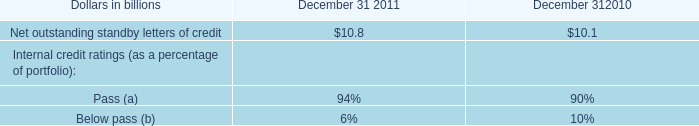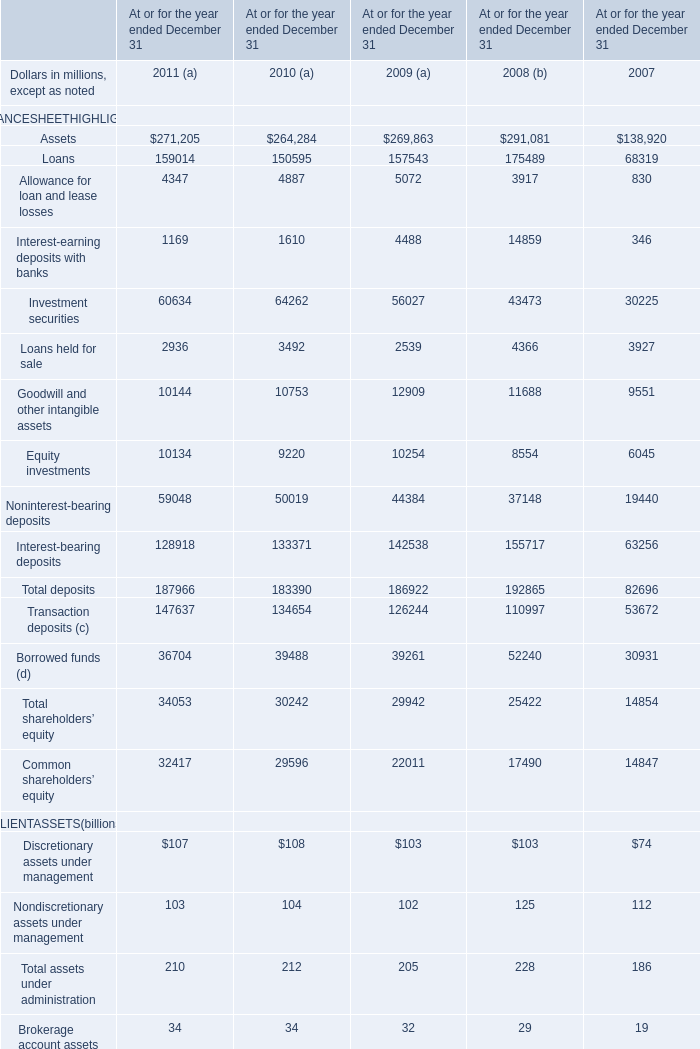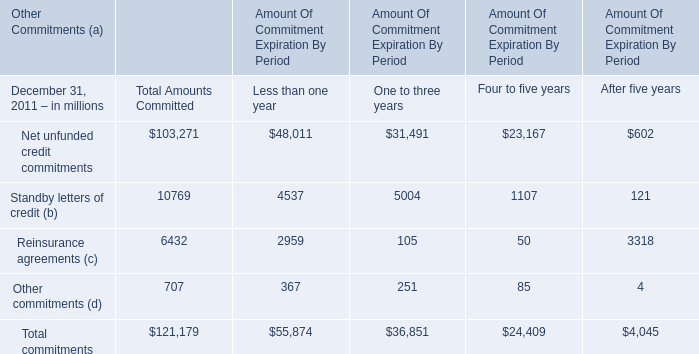what is the total unfunded commitments at december 31 , 2011 including private equity investments and other investments , in millions? 
Computations: (247 + 3)
Answer: 250.0. 